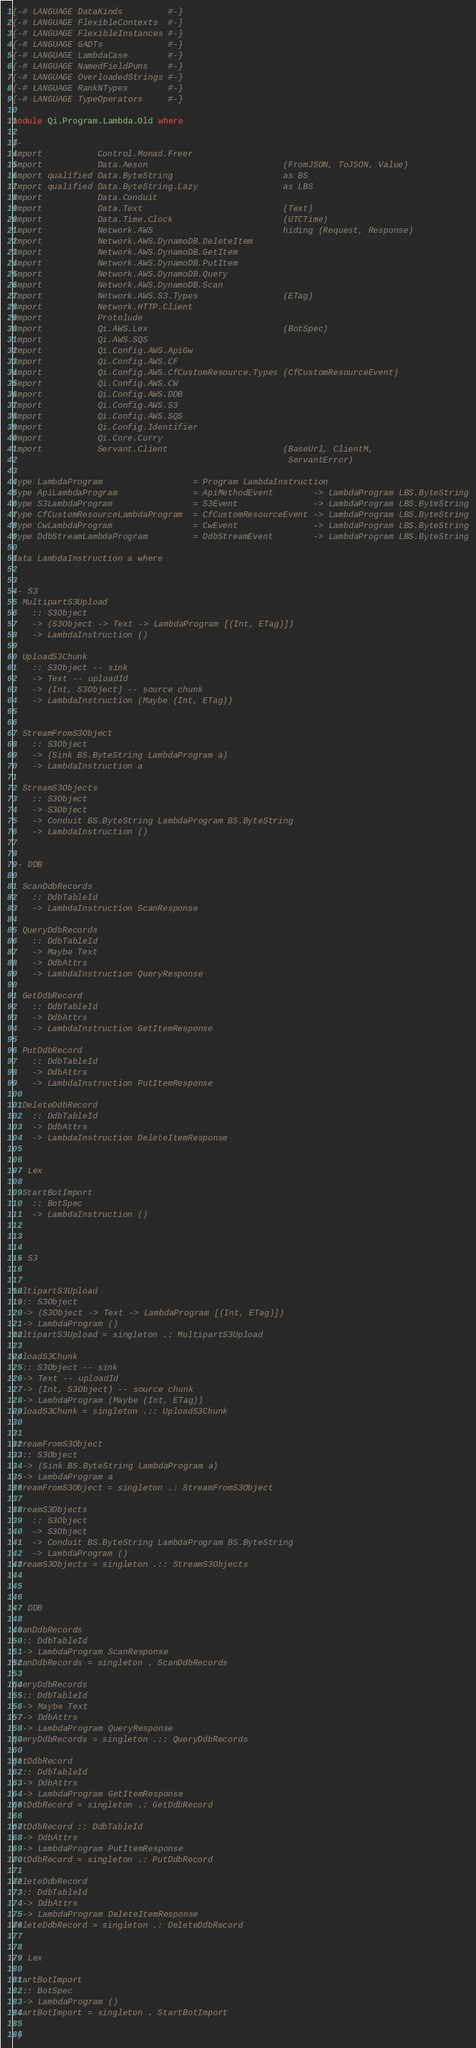Convert code to text. <code><loc_0><loc_0><loc_500><loc_500><_Haskell_>{-# LANGUAGE DataKinds         #-}
{-# LANGUAGE FlexibleContexts  #-}
{-# LANGUAGE FlexibleInstances #-}
{-# LANGUAGE GADTs             #-}
{-# LANGUAGE LambdaCase        #-}
{-# LANGUAGE NamedFieldPuns    #-}
{-# LANGUAGE OverloadedStrings #-}
{-# LANGUAGE RankNTypes        #-}
{-# LANGUAGE TypeOperators     #-}

module Qi.Program.Lambda.Old where

{-
import           Control.Monad.Freer
import           Data.Aeson                           (FromJSON, ToJSON, Value)
import qualified Data.ByteString                      as BS
import qualified Data.ByteString.Lazy                 as LBS
import           Data.Conduit
import           Data.Text                            (Text)
import           Data.Time.Clock                      (UTCTime)
import           Network.AWS                          hiding (Request, Response)
import           Network.AWS.DynamoDB.DeleteItem
import           Network.AWS.DynamoDB.GetItem
import           Network.AWS.DynamoDB.PutItem
import           Network.AWS.DynamoDB.Query
import           Network.AWS.DynamoDB.Scan
import           Network.AWS.S3.Types                 (ETag)
import           Network.HTTP.Client
import           Protolude
import           Qi.AWS.Lex                           (BotSpec)
import           Qi.AWS.SQS
import           Qi.Config.AWS.ApiGw
import           Qi.Config.AWS.CF
import           Qi.Config.AWS.CfCustomResource.Types (CfCustomResourceEvent)
import           Qi.Config.AWS.CW
import           Qi.Config.AWS.DDB
import           Qi.Config.AWS.S3
import           Qi.Config.AWS.SQS
import           Qi.Config.Identifier
import           Qi.Core.Curry
import           Servant.Client                       (BaseUrl, ClientM,
                                                       ServantError)

type LambdaProgram                  = Program LambdaInstruction
type ApiLambdaProgram               = ApiMethodEvent        -> LambdaProgram LBS.ByteString
type S3LambdaProgram                = S3Event               -> LambdaProgram LBS.ByteString
type CfCustomResourceLambdaProgram  = CfCustomResourceEvent -> LambdaProgram LBS.ByteString
type CwLambdaProgram                = CwEvent               -> LambdaProgram LBS.ByteString
type DdbStreamLambdaProgram         = DdbStreamEvent        -> LambdaProgram LBS.ByteString

data LambdaInstruction a where


-- S3
  MultipartS3Upload
    :: S3Object
    -> (S3Object -> Text -> LambdaProgram [(Int, ETag)])
    -> LambdaInstruction ()

  UploadS3Chunk
    :: S3Object -- sink
    -> Text -- uploadId
    -> (Int, S3Object) -- source chunk
    -> LambdaInstruction (Maybe (Int, ETag))


  StreamFromS3Object
    :: S3Object
    -> (Sink BS.ByteString LambdaProgram a)
    -> LambdaInstruction a

  StreamS3Objects
    :: S3Object
    -> S3Object
    -> Conduit BS.ByteString LambdaProgram BS.ByteString
    -> LambdaInstruction ()


-- DDB

  ScanDdbRecords
    :: DdbTableId
    -> LambdaInstruction ScanResponse

  QueryDdbRecords
    :: DdbTableId
    -> Maybe Text
    -> DdbAttrs
    -> LambdaInstruction QueryResponse

  GetDdbRecord
    :: DdbTableId
    -> DdbAttrs
    -> LambdaInstruction GetItemResponse

  PutDdbRecord
    :: DdbTableId
    -> DdbAttrs
    -> LambdaInstruction PutItemResponse

  DeleteDdbRecord
    :: DdbTableId
    -> DdbAttrs
    -> LambdaInstruction DeleteItemResponse


-- Lex

  StartBotImport
    :: BotSpec
    -> LambdaInstruction ()



-- S3


multipartS3Upload
  :: S3Object
  -> (S3Object -> Text -> LambdaProgram [(Int, ETag)])
  -> LambdaProgram ()
multipartS3Upload = singleton .: MultipartS3Upload

uploadS3Chunk
  :: S3Object -- sink
  -> Text -- uploadId
  -> (Int, S3Object) -- source chunk
  -> LambdaProgram (Maybe (Int, ETag))
uploadS3Chunk = singleton .:: UploadS3Chunk


streamFromS3Object
  :: S3Object
  -> (Sink BS.ByteString LambdaProgram a)
  -> LambdaProgram a
streamFromS3Object = singleton .: StreamFromS3Object

streamS3Objects
    :: S3Object
    -> S3Object
    -> Conduit BS.ByteString LambdaProgram BS.ByteString
    -> LambdaProgram ()
streamS3Objects = singleton .:: StreamS3Objects



-- DDB

scanDdbRecords
  :: DdbTableId
  -> LambdaProgram ScanResponse
scanDdbRecords = singleton . ScanDdbRecords

queryDdbRecords
  :: DdbTableId
  -> Maybe Text
  -> DdbAttrs
  -> LambdaProgram QueryResponse
queryDdbRecords = singleton .:: QueryDdbRecords

getDdbRecord
  :: DdbTableId
  -> DdbAttrs
  -> LambdaProgram GetItemResponse
getDdbRecord = singleton .: GetDdbRecord

putDdbRecord :: DdbTableId
  -> DdbAttrs
  -> LambdaProgram PutItemResponse
putDdbRecord = singleton .: PutDdbRecord

deleteDdbRecord
  :: DdbTableId
  -> DdbAttrs
  -> LambdaProgram DeleteItemResponse
deleteDdbRecord = singleton .: DeleteDdbRecord


-- Lex

startBotImport
  :: BotSpec
  -> LambdaProgram ()
startBotImport = singleton . StartBotImport

-}
</code> 